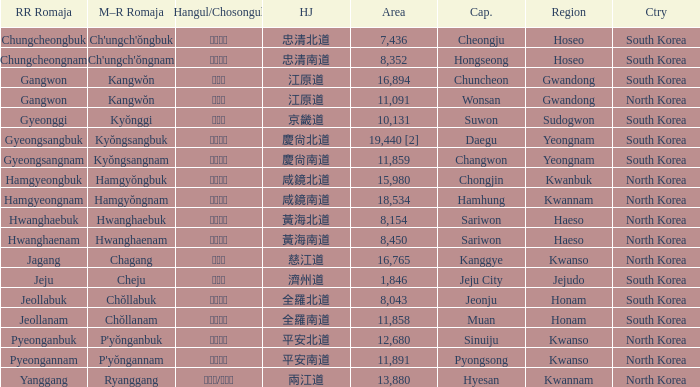What is the area for the province having Hangul of 경기도? 10131.0. 